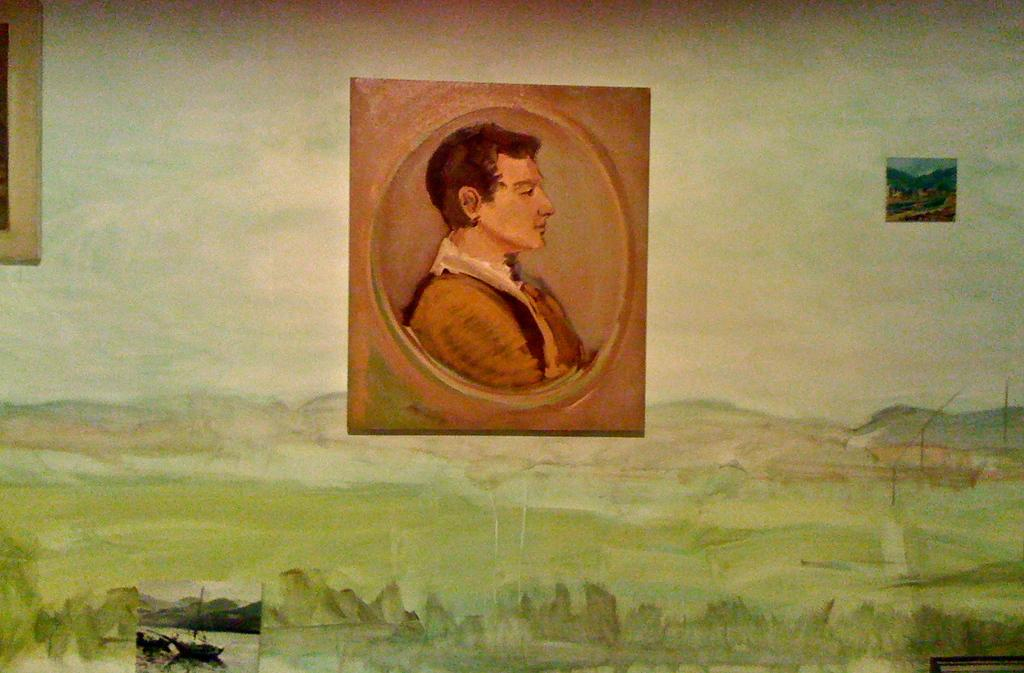What type of artwork is depicted in the image? The image is a painting. What route should be taken to find the key in the painting? There is no key or route present in the painting; it is a visual representation of a scene or subject. 